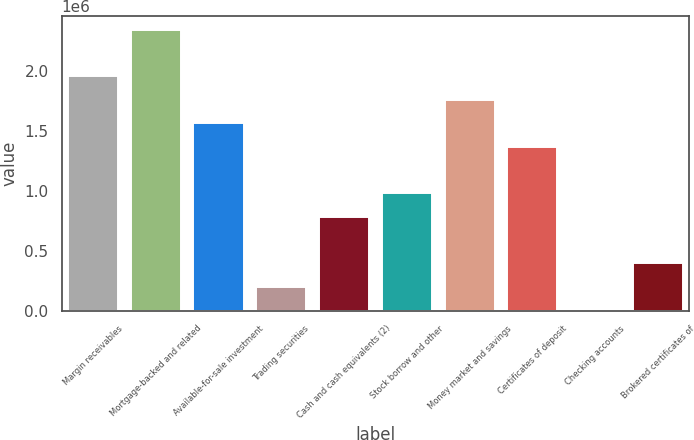Convert chart. <chart><loc_0><loc_0><loc_500><loc_500><bar_chart><fcel>Margin receivables<fcel>Mortgage-backed and related<fcel>Available-for-sale investment<fcel>Trading securities<fcel>Cash and cash equivalents (2)<fcel>Stock borrow and other<fcel>Money market and savings<fcel>Certificates of deposit<fcel>Checking accounts<fcel>Brokered certificates of<nl><fcel>1.9572e+06<fcel>2.3475e+06<fcel>1.5669e+06<fcel>200840<fcel>786294<fcel>981446<fcel>1.76205e+06<fcel>1.37175e+06<fcel>5689<fcel>395992<nl></chart> 